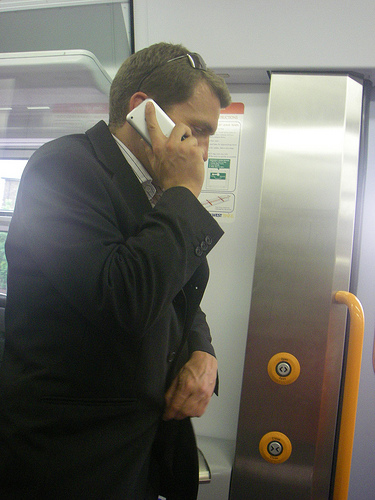What are the expressions and body language of the man indicating? The man's body language, with his hand in his pocket and speaking on the phone, suggests he is focused and perhaps discussing something important. His expression is not fully visible but he seems engaged in the call. 